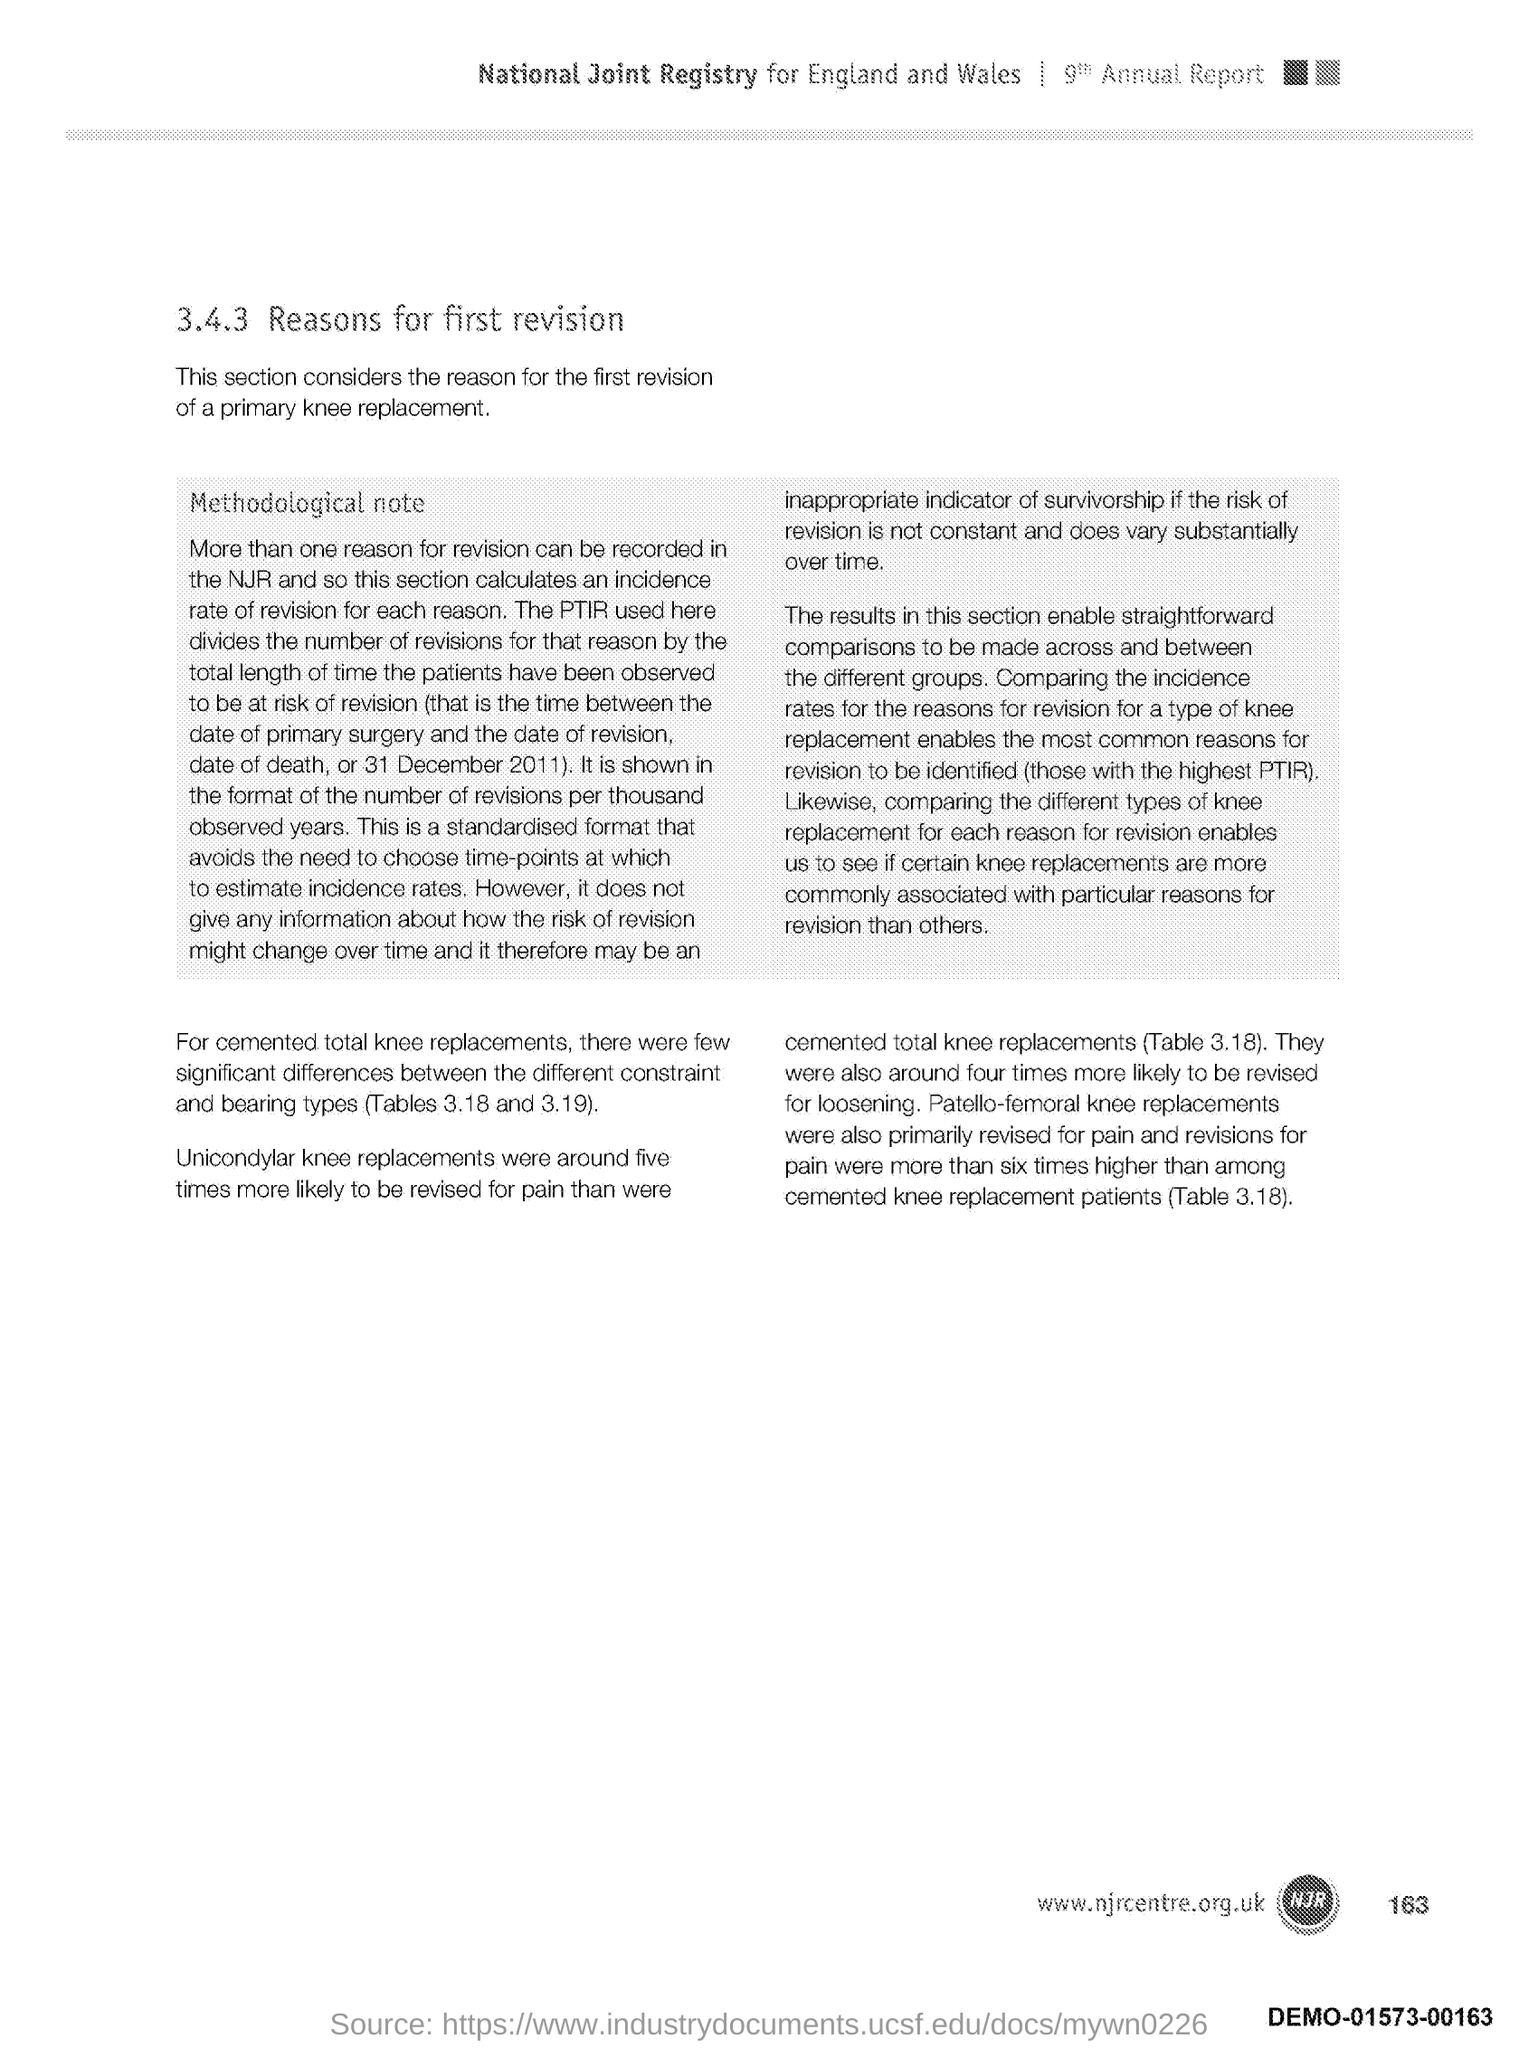Identify some key points in this picture. The number at the bottom right side of the page is 163. 